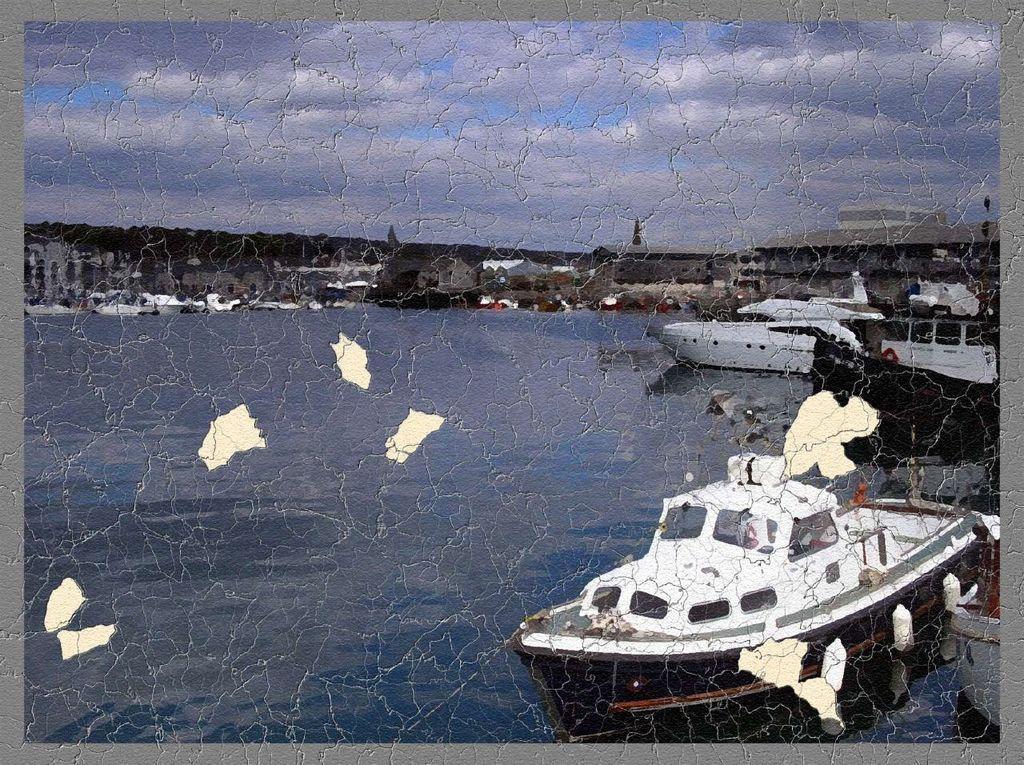In one or two sentences, can you explain what this image depicts? This is an edited image. In this image we can see ships on the water, buildings, trees and sky with clouds. 